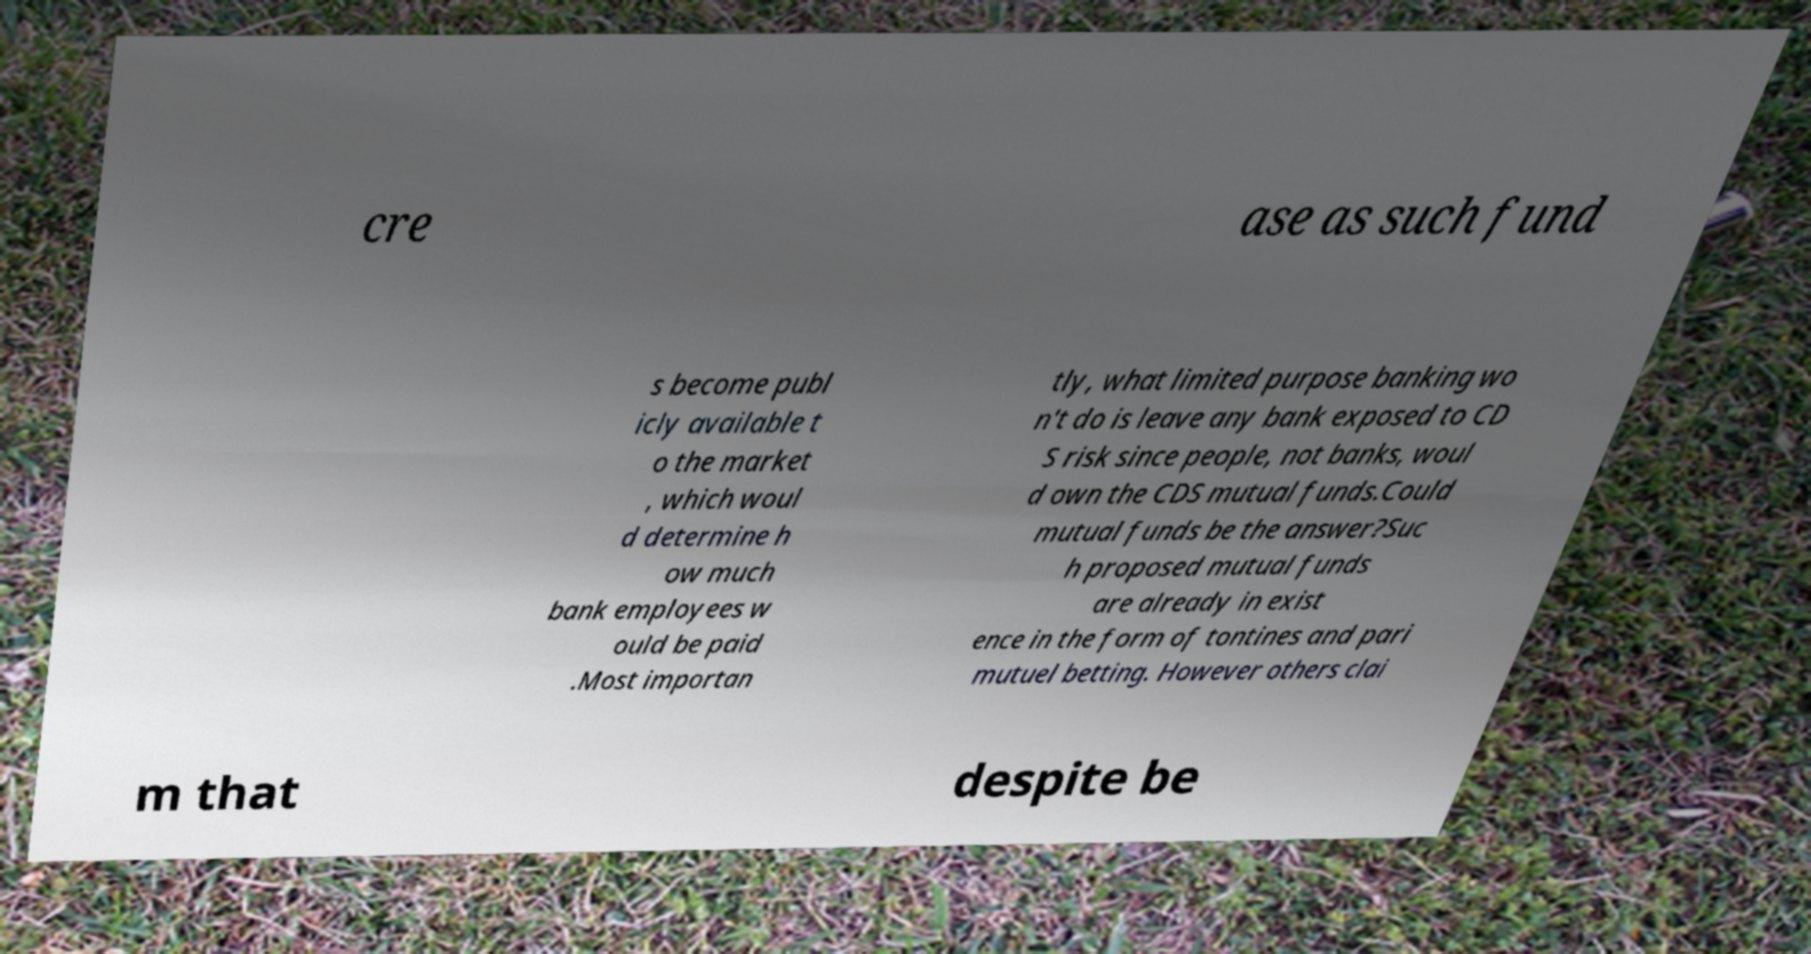Can you read and provide the text displayed in the image?This photo seems to have some interesting text. Can you extract and type it out for me? cre ase as such fund s become publ icly available t o the market , which woul d determine h ow much bank employees w ould be paid .Most importan tly, what limited purpose banking wo n't do is leave any bank exposed to CD S risk since people, not banks, woul d own the CDS mutual funds.Could mutual funds be the answer?Suc h proposed mutual funds are already in exist ence in the form of tontines and pari mutuel betting. However others clai m that despite be 